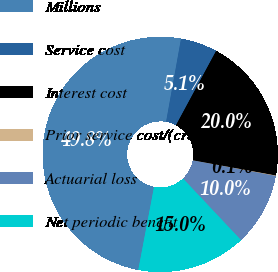Convert chart to OTSL. <chart><loc_0><loc_0><loc_500><loc_500><pie_chart><fcel>Millions<fcel>Service cost<fcel>Interest cost<fcel>Prior service cost/(credit)<fcel>Actuarial loss<fcel>Net periodic benefit<nl><fcel>49.85%<fcel>5.05%<fcel>19.99%<fcel>0.07%<fcel>10.03%<fcel>15.01%<nl></chart> 